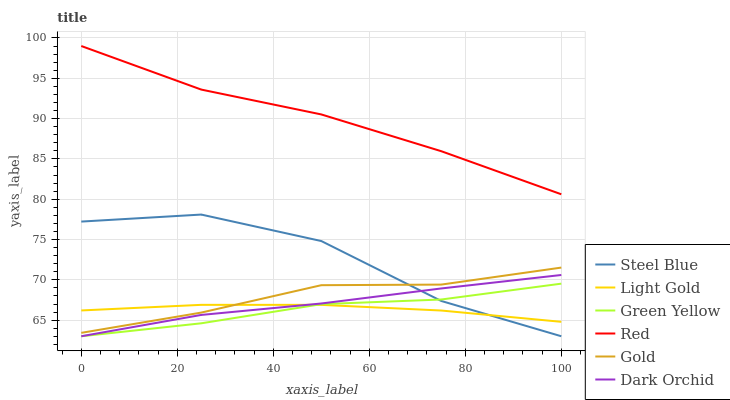Does Steel Blue have the minimum area under the curve?
Answer yes or no. No. Does Steel Blue have the maximum area under the curve?
Answer yes or no. No. Is Steel Blue the smoothest?
Answer yes or no. No. Is Dark Orchid the roughest?
Answer yes or no. No. Does Light Gold have the lowest value?
Answer yes or no. No. Does Steel Blue have the highest value?
Answer yes or no. No. Is Light Gold less than Red?
Answer yes or no. Yes. Is Red greater than Dark Orchid?
Answer yes or no. Yes. Does Light Gold intersect Red?
Answer yes or no. No. 